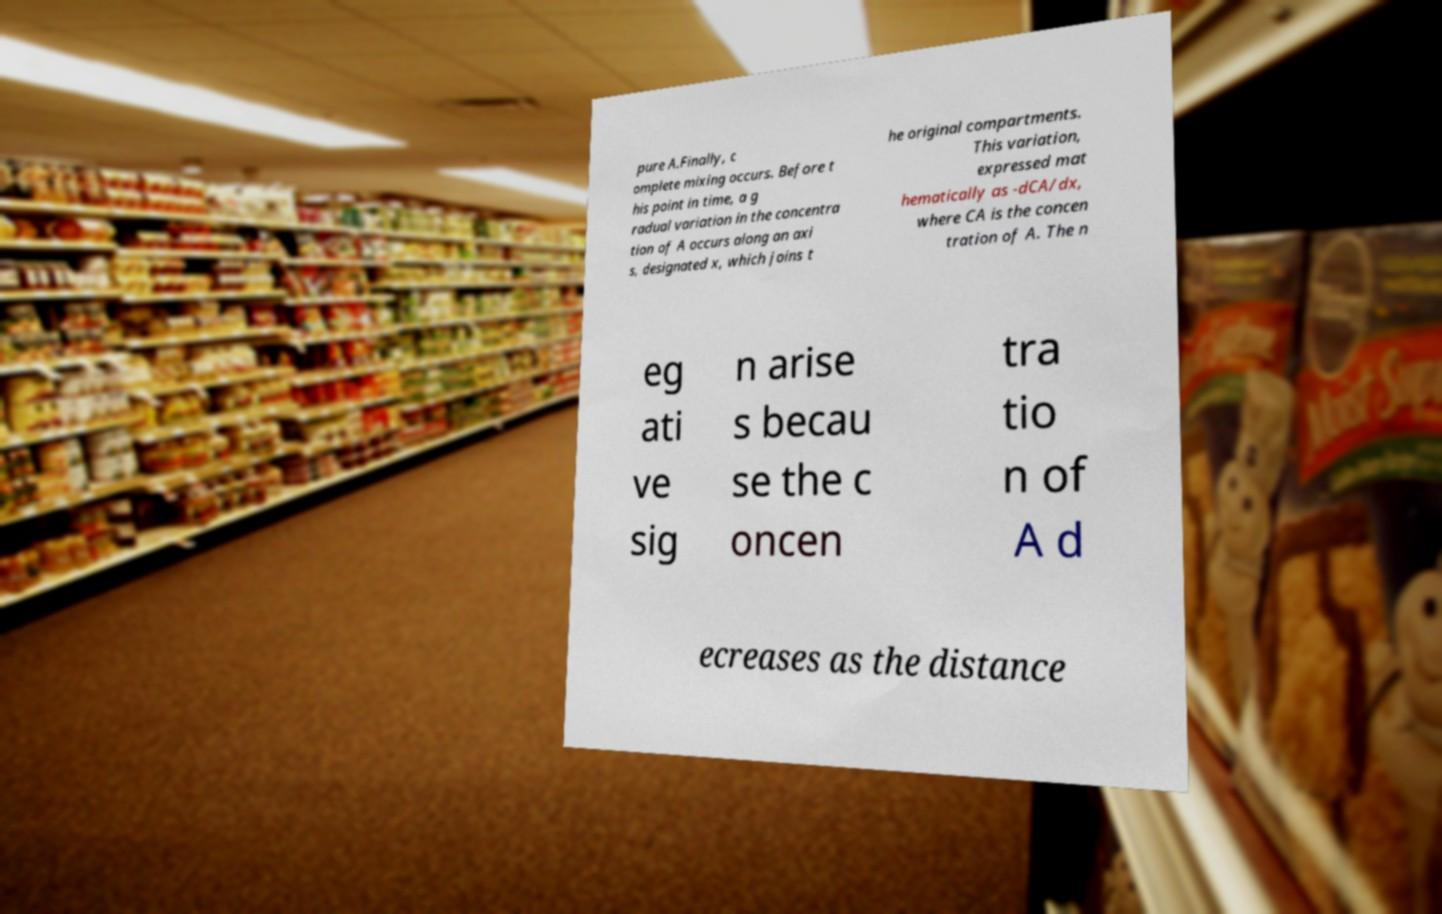Please identify and transcribe the text found in this image. pure A.Finally, c omplete mixing occurs. Before t his point in time, a g radual variation in the concentra tion of A occurs along an axi s, designated x, which joins t he original compartments. This variation, expressed mat hematically as -dCA/dx, where CA is the concen tration of A. The n eg ati ve sig n arise s becau se the c oncen tra tio n of A d ecreases as the distance 